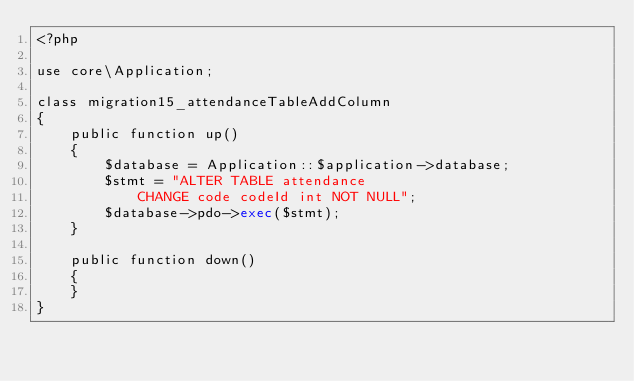Convert code to text. <code><loc_0><loc_0><loc_500><loc_500><_PHP_><?php

use core\Application;

class migration15_attendanceTableAddColumn
{
    public function up()
    {
        $database = Application::$application->database;
        $stmt = "ALTER TABLE attendance 
            CHANGE code codeId int NOT NULL";
        $database->pdo->exec($stmt);
    }

    public function down()
    {
    }
}
</code> 